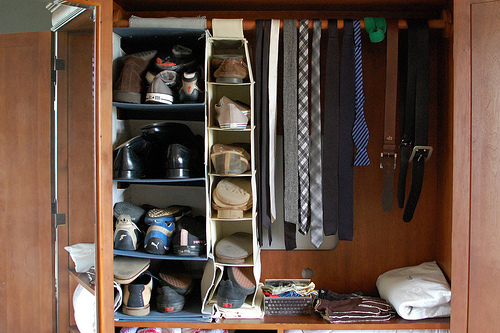<image>
Can you confirm if the hole is in the closet wall? Yes. The hole is contained within or inside the closet wall, showing a containment relationship. 